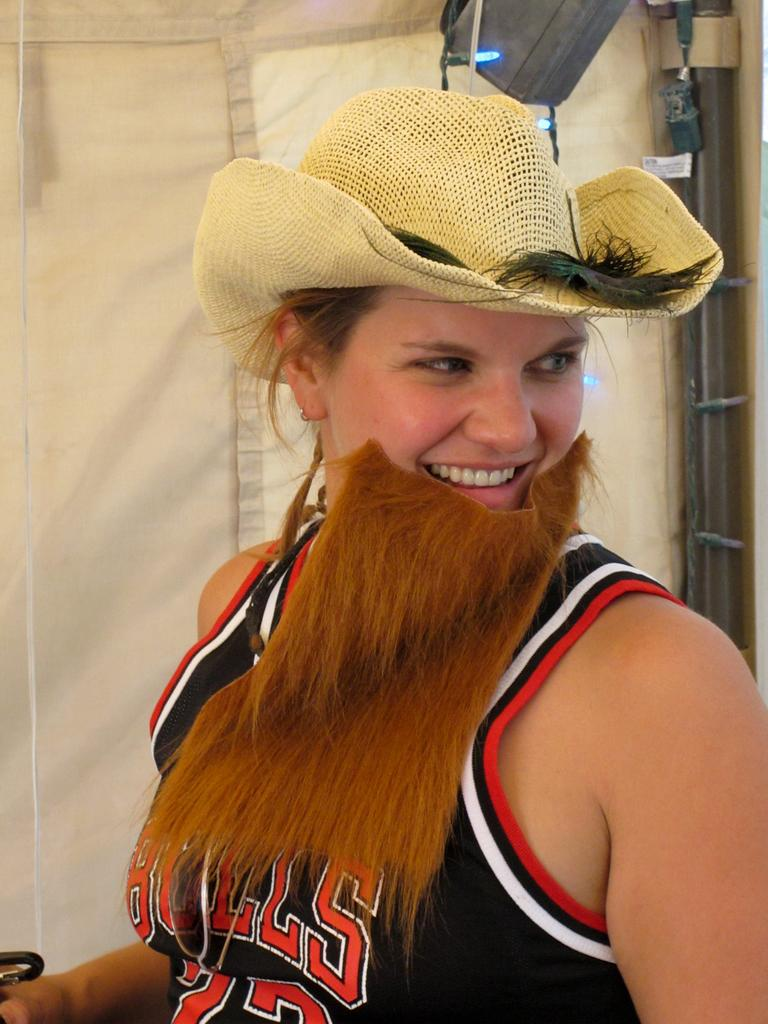<image>
Relay a brief, clear account of the picture shown. A woman with a fake beard and cowboy hat is wearing a Bulls jersey. 